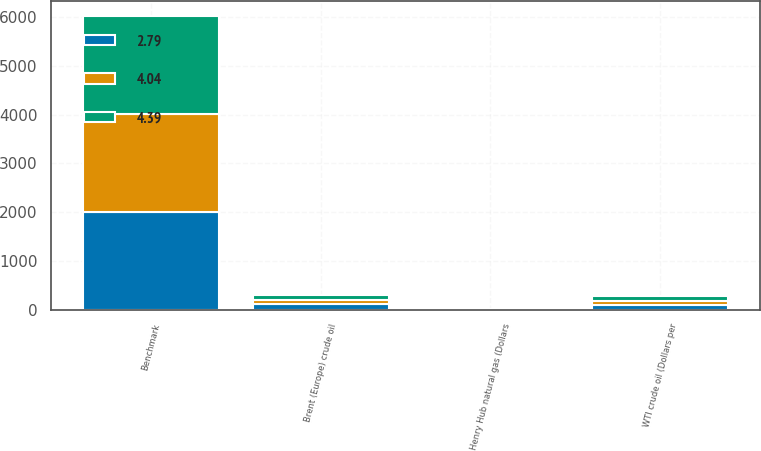Convert chart. <chart><loc_0><loc_0><loc_500><loc_500><stacked_bar_chart><ecel><fcel>Benchmark<fcel>WTI crude oil (Dollars per<fcel>Brent (Europe) crude oil<fcel>Henry Hub natural gas (Dollars<nl><fcel>4.39<fcel>2012<fcel>94.15<fcel>111.65<fcel>2.79<nl><fcel>2.79<fcel>2011<fcel>95.11<fcel>111.26<fcel>4.04<nl><fcel>4.04<fcel>2010<fcel>79.61<fcel>79.51<fcel>4.39<nl></chart> 